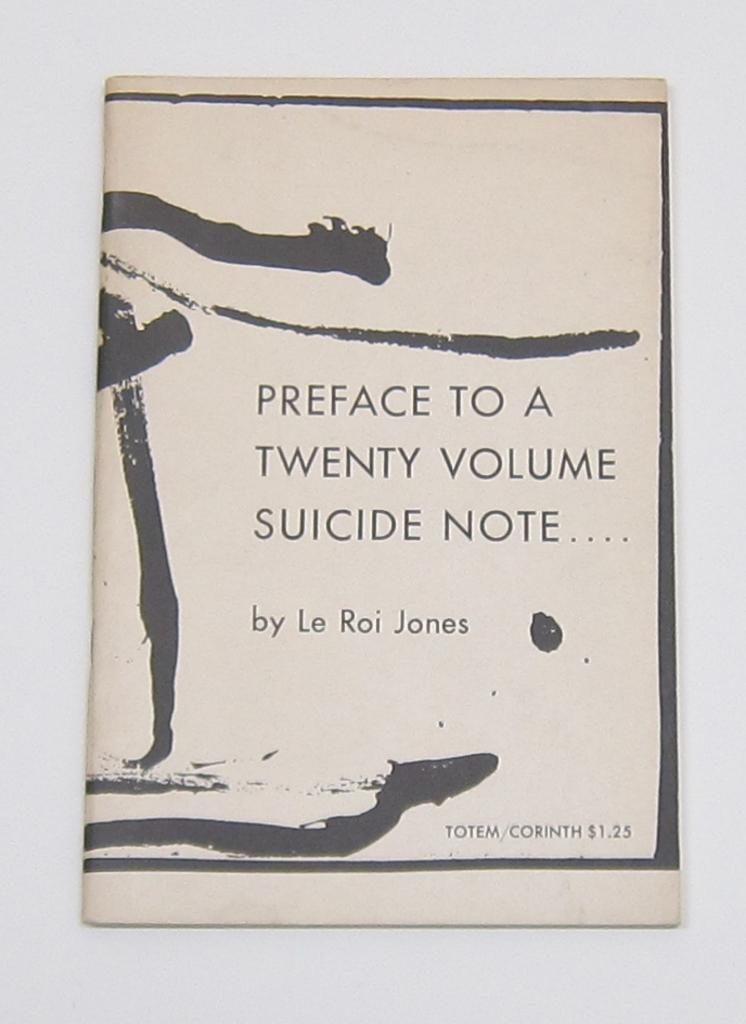What is present in the image that has text on it? There is a paper in the image with text on it. Can you describe the background of the image? The background of the image is blurred. How many ants are crawling on the text in the image? There are no ants present in the image. What type of fang can be seen in the image? There is no fang present in the image. 